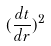Convert formula to latex. <formula><loc_0><loc_0><loc_500><loc_500>( \frac { d t } { d r } ) ^ { 2 }</formula> 